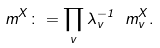Convert formula to latex. <formula><loc_0><loc_0><loc_500><loc_500>\ m ^ { X } \colon = \prod _ { v } \lambda _ { v } ^ { - 1 } \ m _ { v } ^ { X } .</formula> 